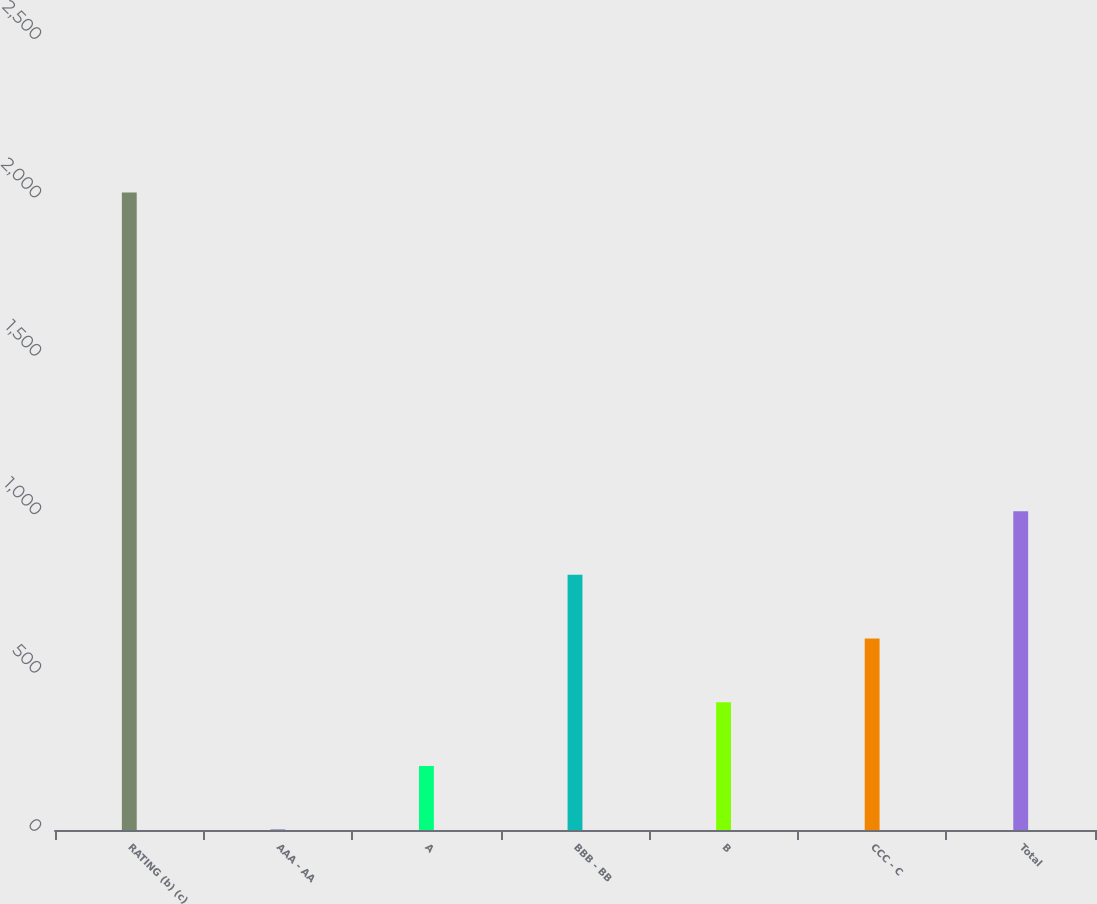Convert chart to OTSL. <chart><loc_0><loc_0><loc_500><loc_500><bar_chart><fcel>RATING (b) (c)<fcel>AAA - AA<fcel>A<fcel>BBB - BB<fcel>B<fcel>CCC - C<fcel>Total<nl><fcel>2012<fcel>1<fcel>202.1<fcel>805.4<fcel>403.2<fcel>604.3<fcel>1006.5<nl></chart> 